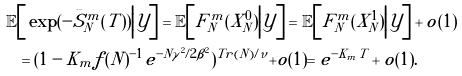Convert formula to latex. <formula><loc_0><loc_0><loc_500><loc_500>\mathbb { E } & \Big [ \exp ( - \bar { S } ^ { m } _ { N } ( T ) ) \Big | \mathcal { Y } \Big ] = \mathbb { E } \Big [ F _ { N } ^ { m } ( X ^ { 0 } _ { N } ) \Big | \mathcal { Y } \Big ] = \mathbb { E } \Big [ F _ { N } ^ { m } ( X ^ { 1 } _ { N } ) \Big | \mathcal { Y } \Big ] + o ( 1 ) \\ & = ( 1 - K _ { m } f ( N ) ^ { - 1 } e ^ { - N \gamma ^ { 2 } / 2 \beta ^ { 2 } } ) ^ { T r ( N ) / \nu } + o ( 1 ) = e ^ { - K _ { m } T } + o ( 1 ) .</formula> 